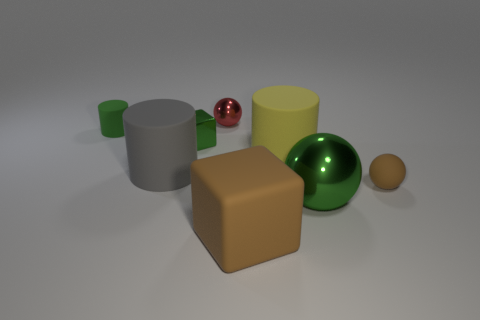What number of other objects are the same color as the rubber ball?
Ensure brevity in your answer.  1. Is there anything else that has the same shape as the gray object?
Provide a succinct answer. Yes. What material is the large object that is the same color as the small cylinder?
Offer a very short reply. Metal. The sphere on the left side of the green metal thing in front of the tiny metallic thing that is on the left side of the red ball is made of what material?
Give a very brief answer. Metal. Do the green object that is in front of the green block and the big gray thing have the same size?
Your answer should be very brief. Yes. How many tiny things are green spheres or metal cubes?
Offer a terse response. 1. Is there a thing of the same color as the small matte sphere?
Your answer should be very brief. Yes. There is a yellow rubber thing that is the same size as the gray matte thing; what is its shape?
Ensure brevity in your answer.  Cylinder. There is a small rubber object left of the tiny matte ball; is it the same color as the metallic cube?
Give a very brief answer. Yes. What number of objects are either green metal cubes that are behind the large yellow rubber object or large green metallic objects?
Give a very brief answer. 2. 